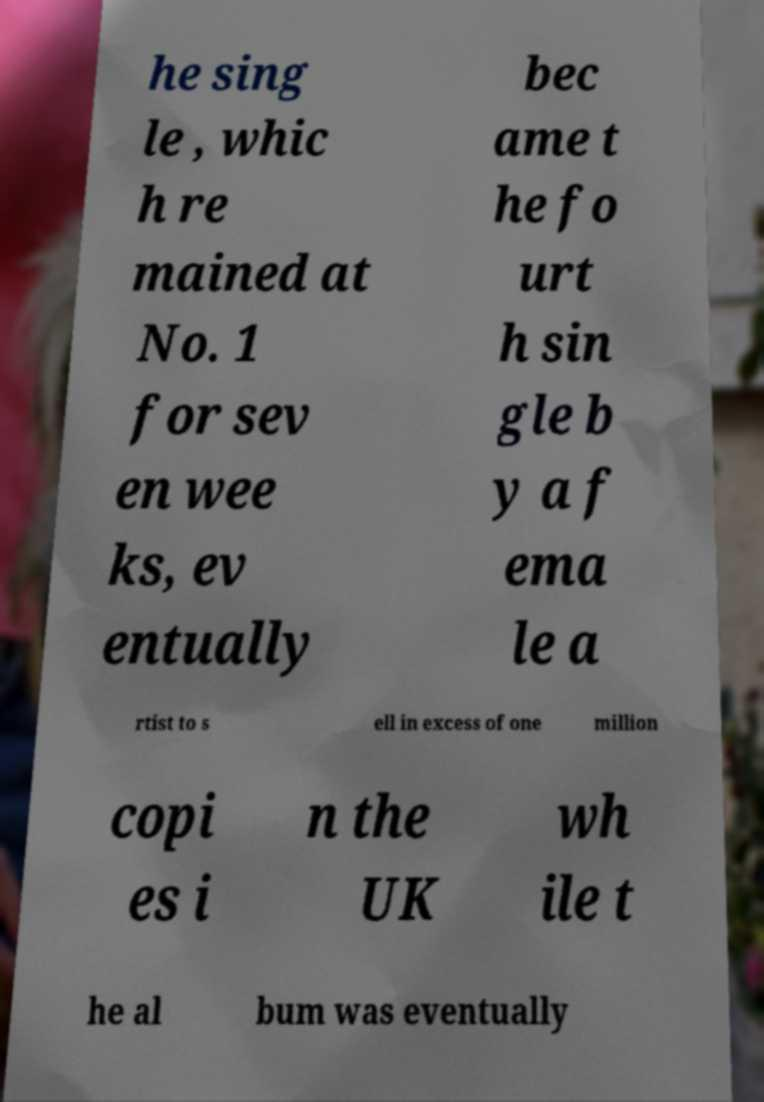Could you assist in decoding the text presented in this image and type it out clearly? he sing le , whic h re mained at No. 1 for sev en wee ks, ev entually bec ame t he fo urt h sin gle b y a f ema le a rtist to s ell in excess of one million copi es i n the UK wh ile t he al bum was eventually 